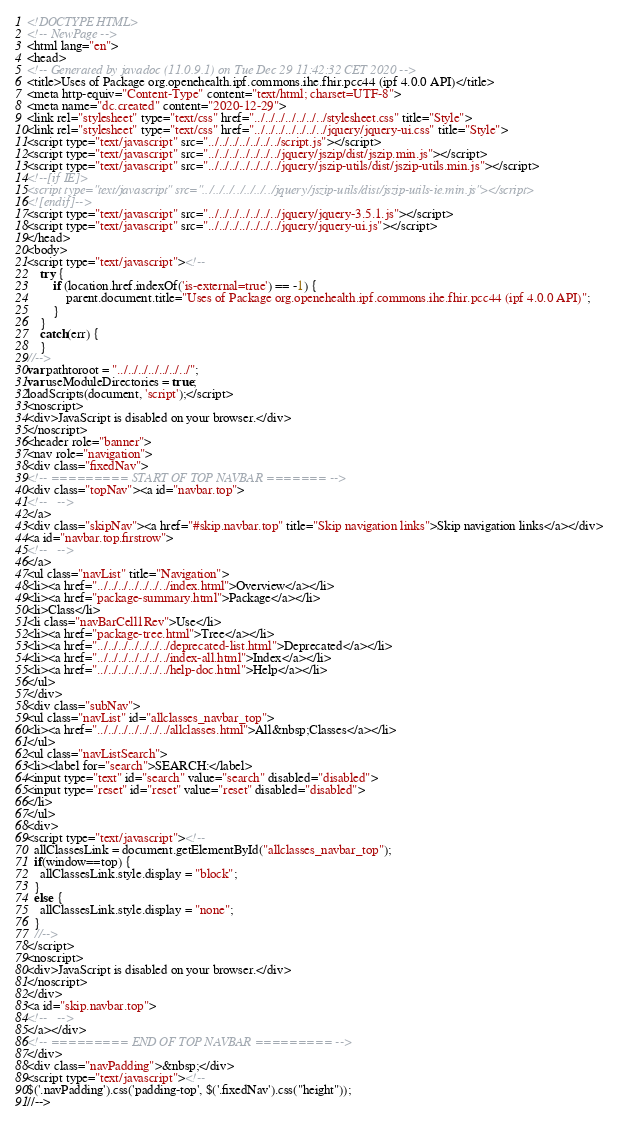<code> <loc_0><loc_0><loc_500><loc_500><_HTML_><!DOCTYPE HTML>
<!-- NewPage -->
<html lang="en">
<head>
<!-- Generated by javadoc (11.0.9.1) on Tue Dec 29 11:42:32 CET 2020 -->
<title>Uses of Package org.openehealth.ipf.commons.ihe.fhir.pcc44 (ipf 4.0.0 API)</title>
<meta http-equiv="Content-Type" content="text/html; charset=UTF-8">
<meta name="dc.created" content="2020-12-29">
<link rel="stylesheet" type="text/css" href="../../../../../../../stylesheet.css" title="Style">
<link rel="stylesheet" type="text/css" href="../../../../../../../jquery/jquery-ui.css" title="Style">
<script type="text/javascript" src="../../../../../../../script.js"></script>
<script type="text/javascript" src="../../../../../../../jquery/jszip/dist/jszip.min.js"></script>
<script type="text/javascript" src="../../../../../../../jquery/jszip-utils/dist/jszip-utils.min.js"></script>
<!--[if IE]>
<script type="text/javascript" src="../../../../../../../jquery/jszip-utils/dist/jszip-utils-ie.min.js"></script>
<![endif]-->
<script type="text/javascript" src="../../../../../../../jquery/jquery-3.5.1.js"></script>
<script type="text/javascript" src="../../../../../../../jquery/jquery-ui.js"></script>
</head>
<body>
<script type="text/javascript"><!--
    try {
        if (location.href.indexOf('is-external=true') == -1) {
            parent.document.title="Uses of Package org.openehealth.ipf.commons.ihe.fhir.pcc44 (ipf 4.0.0 API)";
        }
    }
    catch(err) {
    }
//-->
var pathtoroot = "../../../../../../../";
var useModuleDirectories = true;
loadScripts(document, 'script');</script>
<noscript>
<div>JavaScript is disabled on your browser.</div>
</noscript>
<header role="banner">
<nav role="navigation">
<div class="fixedNav">
<!-- ========= START OF TOP NAVBAR ======= -->
<div class="topNav"><a id="navbar.top">
<!--   -->
</a>
<div class="skipNav"><a href="#skip.navbar.top" title="Skip navigation links">Skip navigation links</a></div>
<a id="navbar.top.firstrow">
<!--   -->
</a>
<ul class="navList" title="Navigation">
<li><a href="../../../../../../../index.html">Overview</a></li>
<li><a href="package-summary.html">Package</a></li>
<li>Class</li>
<li class="navBarCell1Rev">Use</li>
<li><a href="package-tree.html">Tree</a></li>
<li><a href="../../../../../../../deprecated-list.html">Deprecated</a></li>
<li><a href="../../../../../../../index-all.html">Index</a></li>
<li><a href="../../../../../../../help-doc.html">Help</a></li>
</ul>
</div>
<div class="subNav">
<ul class="navList" id="allclasses_navbar_top">
<li><a href="../../../../../../../allclasses.html">All&nbsp;Classes</a></li>
</ul>
<ul class="navListSearch">
<li><label for="search">SEARCH:</label>
<input type="text" id="search" value="search" disabled="disabled">
<input type="reset" id="reset" value="reset" disabled="disabled">
</li>
</ul>
<div>
<script type="text/javascript"><!--
  allClassesLink = document.getElementById("allclasses_navbar_top");
  if(window==top) {
    allClassesLink.style.display = "block";
  }
  else {
    allClassesLink.style.display = "none";
  }
  //-->
</script>
<noscript>
<div>JavaScript is disabled on your browser.</div>
</noscript>
</div>
<a id="skip.navbar.top">
<!--   -->
</a></div>
<!-- ========= END OF TOP NAVBAR ========= -->
</div>
<div class="navPadding">&nbsp;</div>
<script type="text/javascript"><!--
$('.navPadding').css('padding-top', $('.fixedNav').css("height"));
//--></code> 